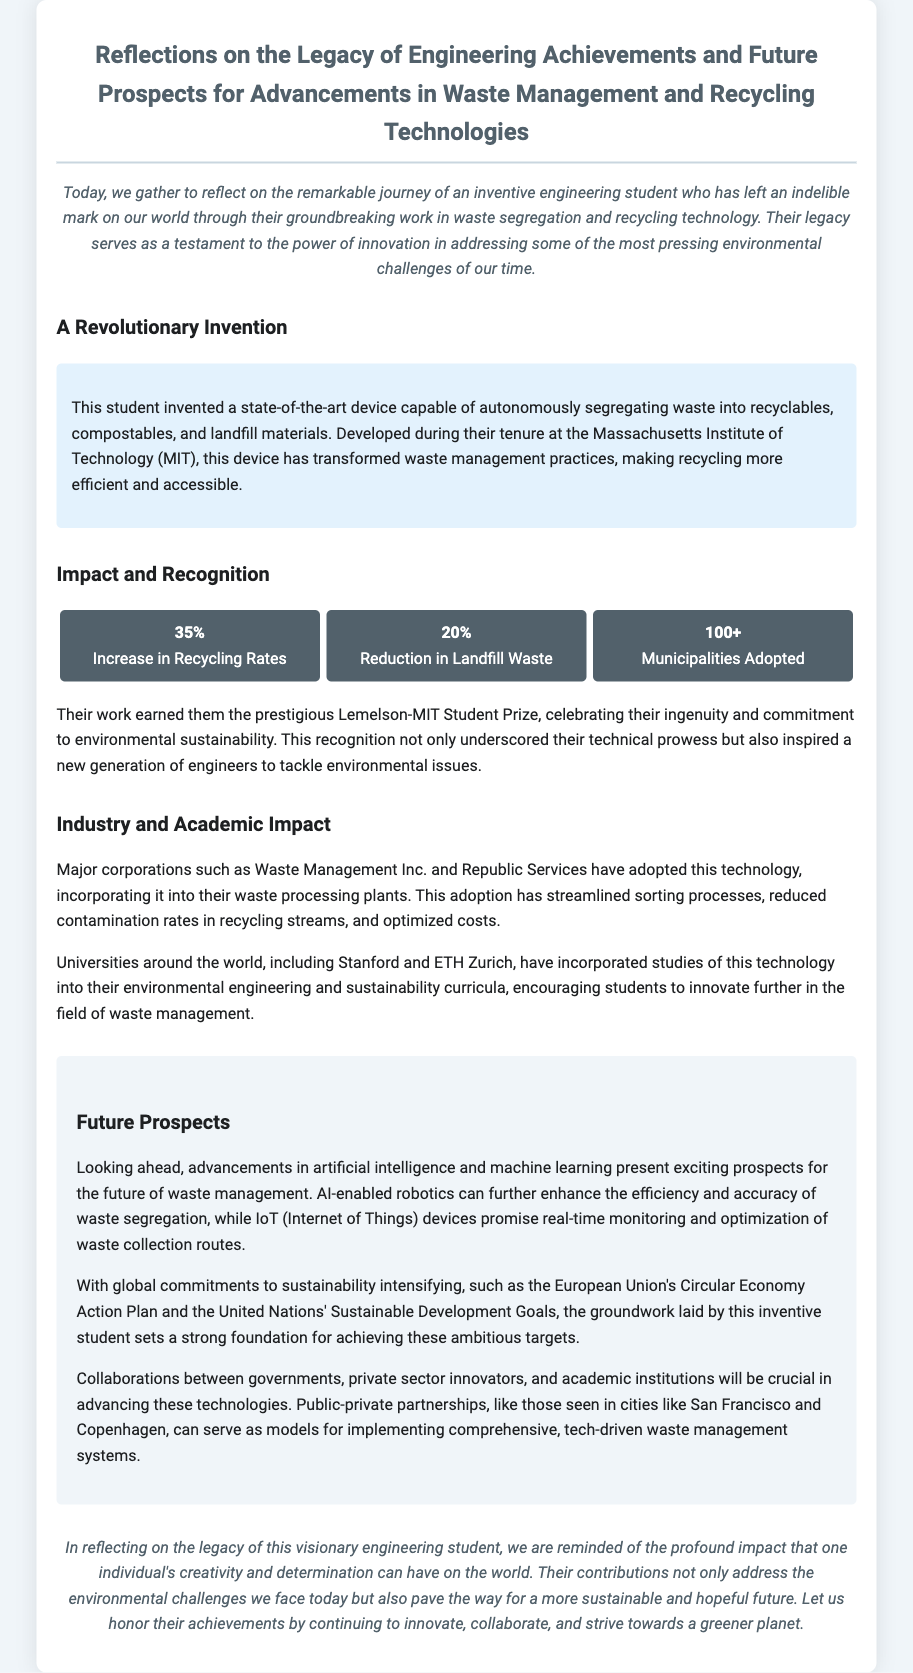What was the student's invention? The invention was a state-of-the-art device capable of autonomously segregating waste.
Answer: device capable of autonomously segregating waste What percentage increase in recycling rates was achieved? The document states that there was a 35% increase in recycling rates due to the invention.
Answer: 35% Which award did the student receive? The student earned the prestigious Lemelson-MIT Student Prize for their work.
Answer: Lemelson-MIT Student Prize What major companies adopted this technology? Major corporations such as Waste Management Inc. and Republic Services adopted the technology.
Answer: Waste Management Inc. and Republic Services What does AI-enabled robotics promise for waste management? AI-enabled robotics can enhance the efficiency and accuracy of waste segregation.
Answer: efficiency and accuracy What are the future prospects in the document related to waste collection? The future prospects include IoT devices for real-time monitoring and optimization of waste collection routes.
Answer: real-time monitoring and optimization What will be crucial for advancing waste management technologies? Collaborations between governments, private sector innovators, and academic institutions will be crucial.
Answer: Collaborations What is the main focus of the eulogy? The main focus is on the legacy of an inventive engineering student and their contributions to waste management.
Answer: legacy of an inventive engineering student What change has the device brought to recycling practices? The device has transformed waste management practices, making recycling more efficient and accessible.
Answer: transformed waste management practices 